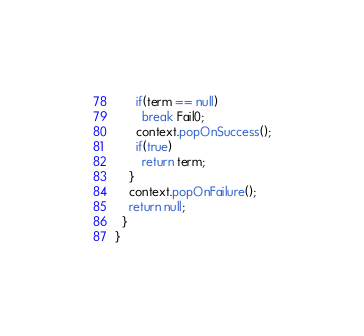Convert code to text. <code><loc_0><loc_0><loc_500><loc_500><_Java_>      if(term == null)
        break Fail0;
      context.popOnSuccess();
      if(true)
        return term;
    }
    context.popOnFailure();
    return null;
  }
}</code> 